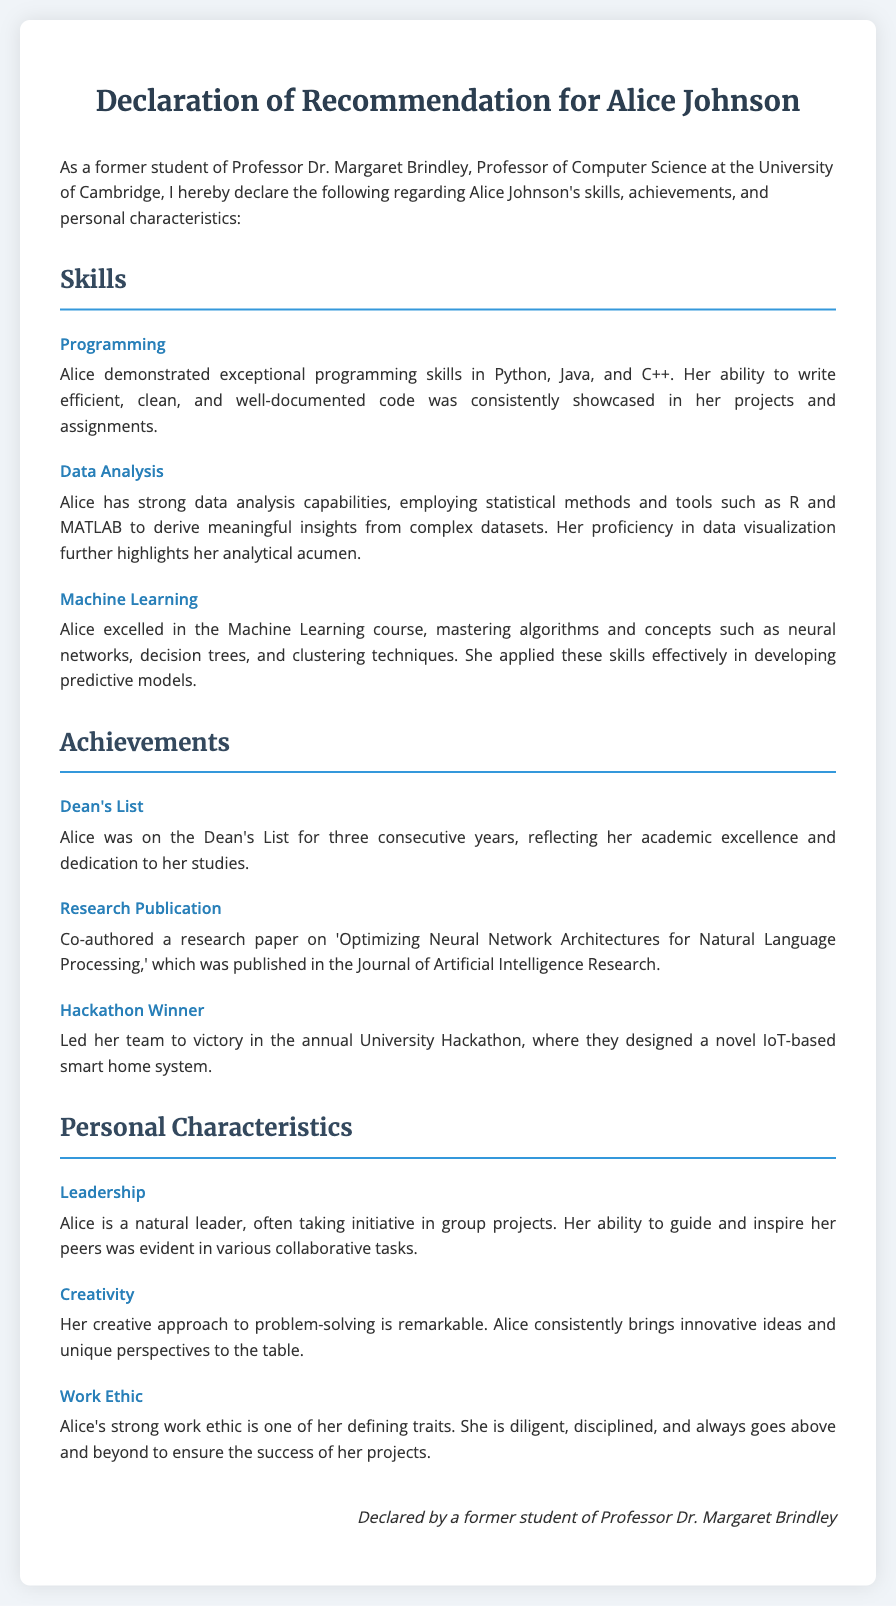What programming languages did Alice demonstrate skills in? The document lists Python, Java, and C++ as the programming languages in which Alice demonstrated exceptional skills.
Answer: Python, Java, C++ How many years was Alice on the Dean's List? Alice's achievement of being on the Dean's List for three consecutive years indicates the number of years.
Answer: three What was the title of the research paper that Alice co-authored? The title of the research paper that Alice co-authored is specified in the document as 'Optimizing Neural Network Architectures for Natural Language Processing.'
Answer: Optimizing Neural Network Architectures for Natural Language Processing Which personal characteristic highlights Alice's ability to guide others? The document specifically points to 'Leadership' as a personal characteristic that describes Alice's ability to guide and inspire her peers.
Answer: Leadership What did Alice's team design to win the hackathon? The document states that Alice's team designed a novel IoT-based smart home system to achieve victory in the hackathon.
Answer: IoT-based smart home system Which statistical tools did Alice employ for data analysis? The tools mentioned in the document that Alice used for data analysis include R and MATLAB.
Answer: R and MATLAB What characteristic is described as one of Alice's defining traits? The document highlights Alice's 'strong work ethic' as one of her defining traits, emphasizing her diligence and discipline.
Answer: strong work ethic What type of document is this declaration primarily about? The document serves as a declaration of recommendation focused on skills, achievements, and personal characteristics of Alice Johnson.
Answer: recommendation 